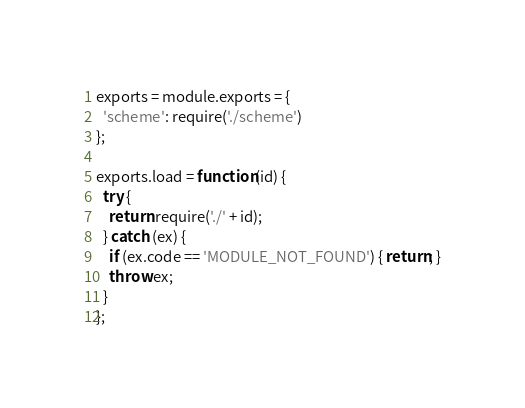<code> <loc_0><loc_0><loc_500><loc_500><_JavaScript_>exports = module.exports = {
  'scheme': require('./scheme')
};

exports.load = function(id) {
  try {
    return require('./' + id);
  } catch (ex) {
    if (ex.code == 'MODULE_NOT_FOUND') { return; }
    throw ex;
  }
};
</code> 